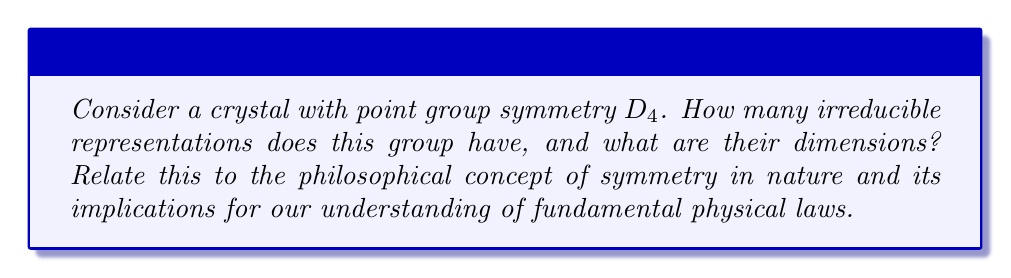Give your solution to this math problem. To solve this problem, we'll follow these steps:

1) First, recall that the dihedral group $D_4$ has 8 elements:
   $$D_4 = \{e, r, r^2, r^3, s, sr, sr^2, sr^3\}$$
   where $e$ is the identity, $r$ is a 90° rotation, and $s$ is a reflection.

2) The number of irreducible representations is equal to the number of conjugacy classes. Let's determine these:
   - $\{e\}$
   - $\{r, r^3\}$
   - $\{r^2\}$
   - $\{s, sr^2\}$
   - $\{sr, sr^3\}$

   There are 5 conjugacy classes, so there are 5 irreducible representations.

3) To find the dimensions of these representations, we use the formula:
   $$\sum_{i=1}^k n_i^2 = |G|$$
   where $k$ is the number of irreducible representations, $n_i$ are their dimensions, and $|G|$ is the order of the group.

4) We know that the trivial representation is always 1-dimensional. Given the structure of $D_4$, we can deduce that there are four 1-dimensional representations and one 2-dimensional representation:
   $$1^2 + 1^2 + 1^2 + 1^2 + 2^2 = 8 = |D_4|$$

5) Philosophical implications:
   The existence of these specific representations reflects the inherent symmetries in the crystal structure. This connects to the philosophical concept that fundamental physical laws and structures in nature often exhibit symmetry. The fact that we can describe complex crystal structures using group theory suggests a deep, mathematical order underlying physical reality.

   Moreover, the irreducible representations correspond to fundamental modes of vibration or electronic states in the crystal. This illustrates how abstract mathematical concepts (group representations) can have concrete physical manifestations, bridging the gap between pure mathematics and observable phenomena.

   The connection between symmetry groups and physical properties also relates to the philosophical principle of invariance - the idea that fundamental laws should remain unchanged under certain transformations. This principle has been crucial in the development of modern physics, from special relativity to particle physics.
Answer: 5 irreducible representations: four 1-dimensional and one 2-dimensional 